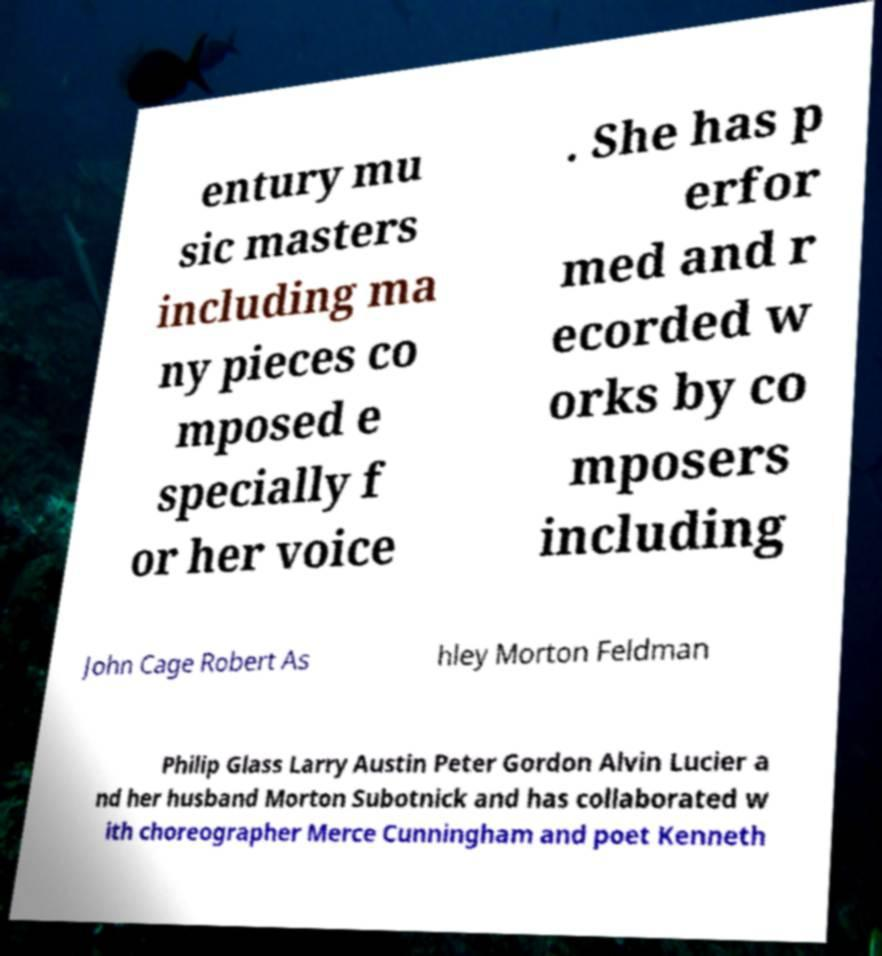Can you accurately transcribe the text from the provided image for me? entury mu sic masters including ma ny pieces co mposed e specially f or her voice . She has p erfor med and r ecorded w orks by co mposers including John Cage Robert As hley Morton Feldman Philip Glass Larry Austin Peter Gordon Alvin Lucier a nd her husband Morton Subotnick and has collaborated w ith choreographer Merce Cunningham and poet Kenneth 